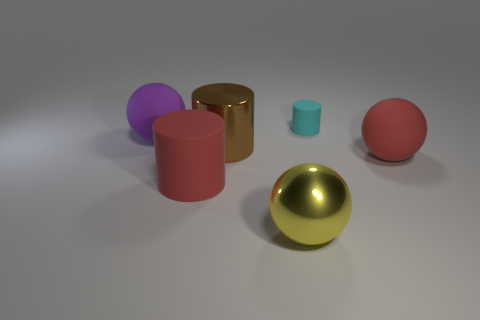There is a matte ball that is the same color as the large rubber cylinder; what size is it?
Provide a succinct answer. Large. What number of balls are small yellow objects or yellow objects?
Ensure brevity in your answer.  1. Does the large yellow thing that is to the left of the cyan cylinder have the same shape as the red object that is on the right side of the large shiny cylinder?
Your response must be concise. Yes. What material is the small object?
Your answer should be compact. Rubber. What shape is the matte thing that is the same color as the big rubber cylinder?
Your response must be concise. Sphere. What number of blue things have the same size as the purple sphere?
Make the answer very short. 0. How many objects are big matte spheres to the right of the cyan matte cylinder or spheres left of the small cyan matte cylinder?
Your answer should be very brief. 3. Are the big red thing that is left of the brown thing and the large ball that is left of the big metal sphere made of the same material?
Your answer should be very brief. Yes. There is a rubber thing that is behind the large rubber sphere that is left of the small matte object; what shape is it?
Your answer should be compact. Cylinder. Is there anything else of the same color as the large metal cylinder?
Keep it short and to the point. No. 